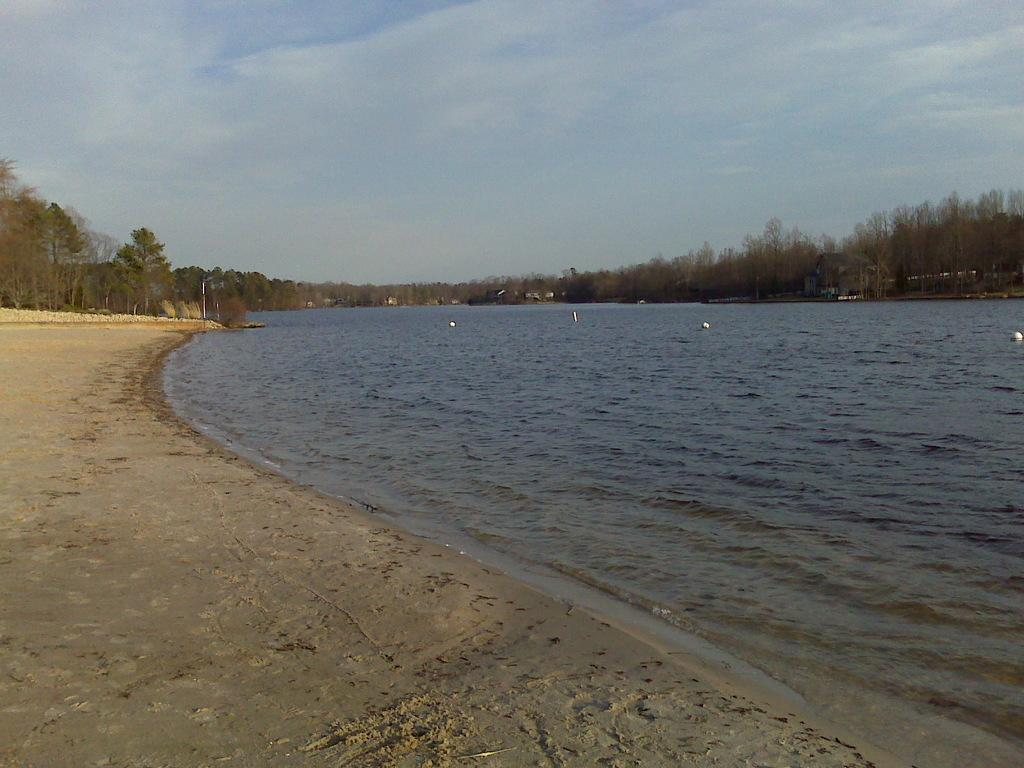What is the main subject of the image? There is a group of objects floating on water in the image. What can be seen in the background of the image? There is a group of trees and poles in the background of the image. What is the condition of the sky in the image? The sky is visible in the background of the image, and it appears to be cloudy. What type of noise can be heard coming from the cattle in the image? There are no cattle present in the image, so no noise can be heard from them. 